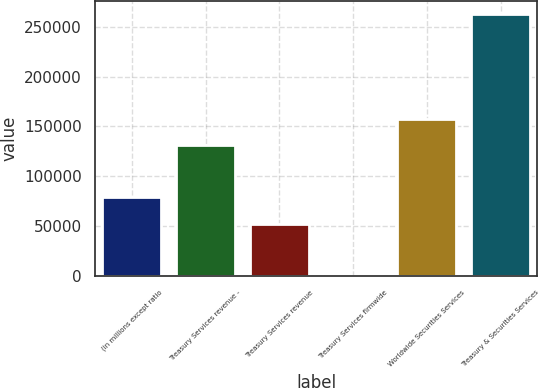Convert chart. <chart><loc_0><loc_0><loc_500><loc_500><bar_chart><fcel>(in millions except ratio<fcel>Treasury Services revenue -<fcel>Treasury Services revenue<fcel>Treasury Services firmwide<fcel>Worldwide Securities Services<fcel>Treasury & Securities Services<nl><fcel>78842.6<fcel>131367<fcel>52580.4<fcel>56<fcel>157629<fcel>262678<nl></chart> 